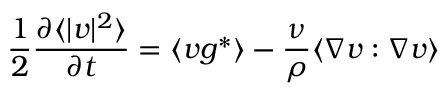<formula> <loc_0><loc_0><loc_500><loc_500>\frac { 1 } { 2 } \frac { \partial \langle | v | ^ { 2 } \rangle } { \partial t } = \langle v g ^ { * } \rangle - \frac { \nu } { \rho } \langle \nabla v \colon \nabla v \rangle</formula> 